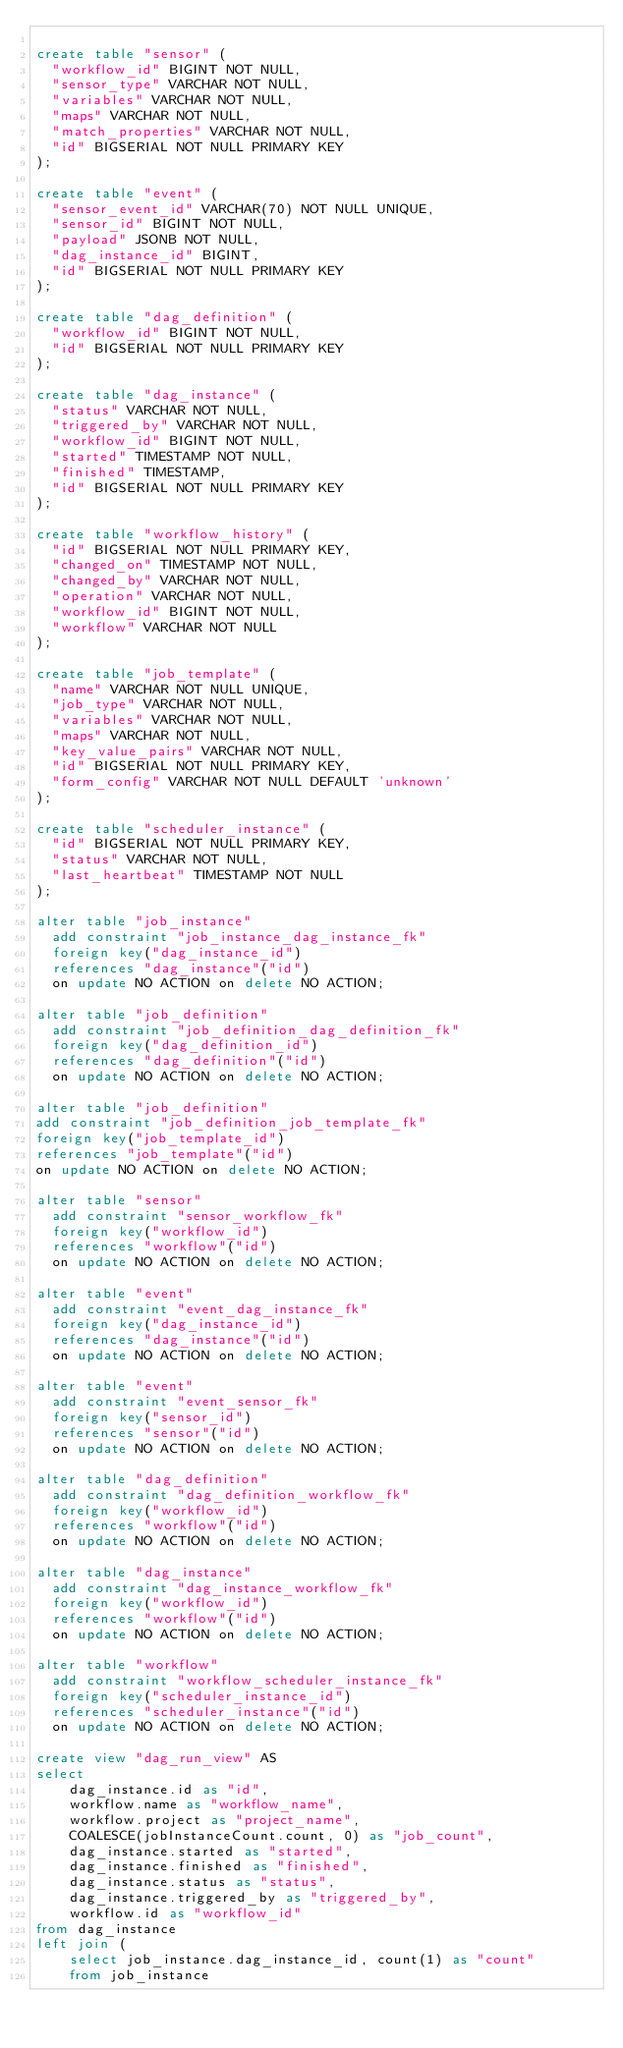<code> <loc_0><loc_0><loc_500><loc_500><_SQL_>
create table "sensor" (
  "workflow_id" BIGINT NOT NULL,
  "sensor_type" VARCHAR NOT NULL,
  "variables" VARCHAR NOT NULL,
  "maps" VARCHAR NOT NULL,
  "match_properties" VARCHAR NOT NULL,
  "id" BIGSERIAL NOT NULL PRIMARY KEY
);

create table "event" (
  "sensor_event_id" VARCHAR(70) NOT NULL UNIQUE,
  "sensor_id" BIGINT NOT NULL,
  "payload" JSONB NOT NULL,
  "dag_instance_id" BIGINT,
  "id" BIGSERIAL NOT NULL PRIMARY KEY
);

create table "dag_definition" (
  "workflow_id" BIGINT NOT NULL,
  "id" BIGSERIAL NOT NULL PRIMARY KEY
);

create table "dag_instance" (
  "status" VARCHAR NOT NULL,
  "triggered_by" VARCHAR NOT NULL,
  "workflow_id" BIGINT NOT NULL,
  "started" TIMESTAMP NOT NULL,
  "finished" TIMESTAMP,
  "id" BIGSERIAL NOT NULL PRIMARY KEY
);

create table "workflow_history" (
  "id" BIGSERIAL NOT NULL PRIMARY KEY,
  "changed_on" TIMESTAMP NOT NULL,
  "changed_by" VARCHAR NOT NULL,
  "operation" VARCHAR NOT NULL,
  "workflow_id" BIGINT NOT NULL,
  "workflow" VARCHAR NOT NULL
);

create table "job_template" (
  "name" VARCHAR NOT NULL UNIQUE,
  "job_type" VARCHAR NOT NULL,
  "variables" VARCHAR NOT NULL,
  "maps" VARCHAR NOT NULL,
  "key_value_pairs" VARCHAR NOT NULL,
  "id" BIGSERIAL NOT NULL PRIMARY KEY,
  "form_config" VARCHAR NOT NULL DEFAULT 'unknown'
);

create table "scheduler_instance" (
  "id" BIGSERIAL NOT NULL PRIMARY KEY,
  "status" VARCHAR NOT NULL,
  "last_heartbeat" TIMESTAMP NOT NULL
);

alter table "job_instance"
  add constraint "job_instance_dag_instance_fk"
  foreign key("dag_instance_id")
  references "dag_instance"("id")
  on update NO ACTION on delete NO ACTION;

alter table "job_definition"
  add constraint "job_definition_dag_definition_fk"
  foreign key("dag_definition_id")
  references "dag_definition"("id")
  on update NO ACTION on delete NO ACTION;

alter table "job_definition"
add constraint "job_definition_job_template_fk"
foreign key("job_template_id")
references "job_template"("id")
on update NO ACTION on delete NO ACTION;

alter table "sensor"
  add constraint "sensor_workflow_fk"
  foreign key("workflow_id")
  references "workflow"("id")
  on update NO ACTION on delete NO ACTION;

alter table "event"
  add constraint "event_dag_instance_fk"
  foreign key("dag_instance_id")
  references "dag_instance"("id")
  on update NO ACTION on delete NO ACTION;

alter table "event"
  add constraint "event_sensor_fk"
  foreign key("sensor_id")
  references "sensor"("id")
  on update NO ACTION on delete NO ACTION;

alter table "dag_definition"
  add constraint "dag_definition_workflow_fk"
  foreign key("workflow_id")
  references "workflow"("id")
  on update NO ACTION on delete NO ACTION;

alter table "dag_instance"
  add constraint "dag_instance_workflow_fk"
  foreign key("workflow_id")
  references "workflow"("id")
  on update NO ACTION on delete NO ACTION;

alter table "workflow"
  add constraint "workflow_scheduler_instance_fk"
  foreign key("scheduler_instance_id")
  references "scheduler_instance"("id")
  on update NO ACTION on delete NO ACTION;

create view "dag_run_view" AS
select
    dag_instance.id as "id",
    workflow.name as "workflow_name",
    workflow.project as "project_name",
    COALESCE(jobInstanceCount.count, 0) as "job_count",
    dag_instance.started as "started",
    dag_instance.finished as "finished",
    dag_instance.status as "status",
    dag_instance.triggered_by as "triggered_by",
    workflow.id as "workflow_id"
from dag_instance
left join (
    select job_instance.dag_instance_id, count(1) as "count"
    from job_instance</code> 